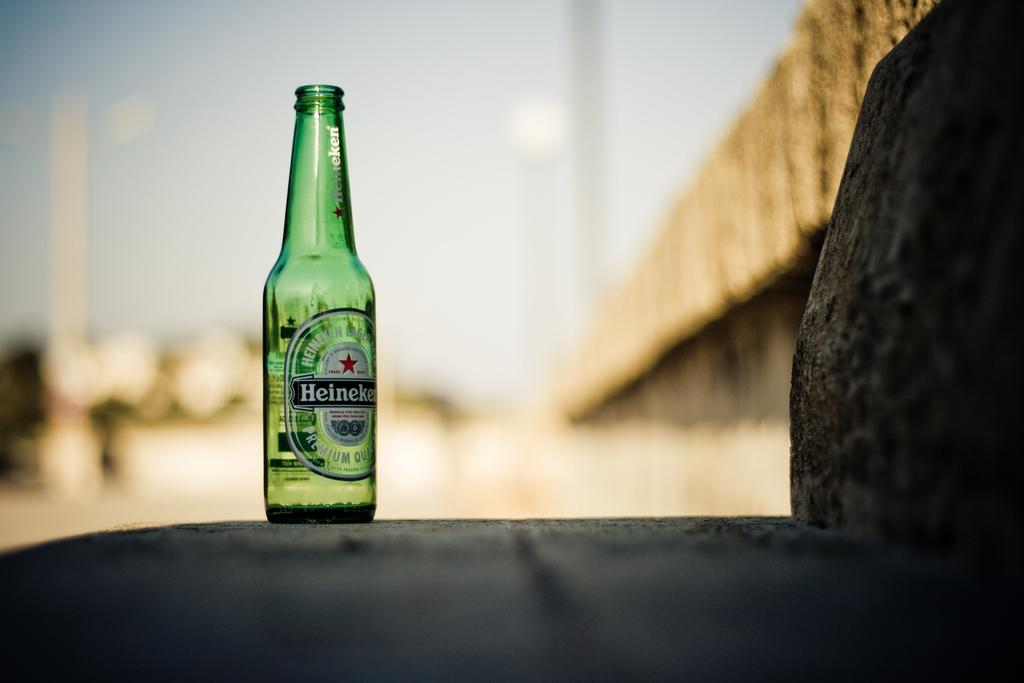<image>
Provide a brief description of the given image. A lone bottle of Heineken on a stone ledge. 